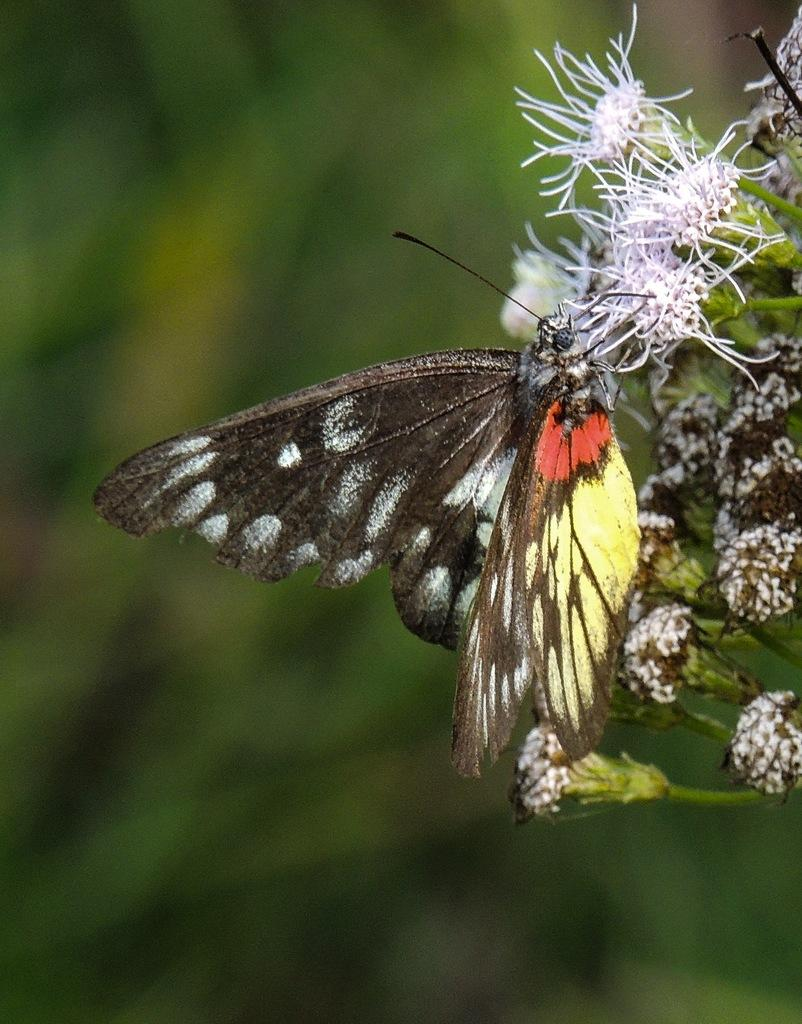What is on the flower in the image? There is a butterfly on a flower in the image. What color are the flowers on the plant? The flowers on the plant are white. How is the image at the back? The image is blurry at the back. What type of leather is visible on the bells in the image? There are no bells or leather present in the image; it features a butterfly on a white flower. 